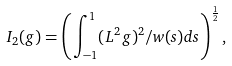<formula> <loc_0><loc_0><loc_500><loc_500>I _ { 2 } ( g ) = \left ( \int _ { - 1 } ^ { 1 } ( L ^ { 2 } g ) ^ { 2 } / w ( s ) d s \right ) ^ { \frac { 1 } { 2 } } ,</formula> 